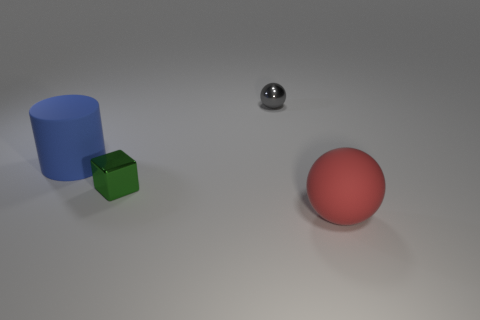What color is the ball behind the sphere in front of the small object that is on the right side of the tiny block?
Your answer should be very brief. Gray. Are the sphere that is in front of the large blue cylinder and the big object that is behind the red matte sphere made of the same material?
Offer a very short reply. Yes. What number of things are either red spheres in front of the green metallic block or big blue objects?
Provide a succinct answer. 2. How many things are large blue shiny cylinders or things that are on the left side of the gray metal object?
Your response must be concise. 2. How many objects are the same size as the gray metal ball?
Your answer should be compact. 1. Is the number of blue cylinders that are in front of the tiny metal cube less than the number of things behind the rubber sphere?
Ensure brevity in your answer.  Yes. How many shiny objects are either red things or small green cylinders?
Provide a succinct answer. 0. What is the shape of the red matte thing?
Provide a short and direct response. Sphere. What material is the red ball that is the same size as the blue rubber thing?
Provide a succinct answer. Rubber. What number of small objects are either matte balls or blue cylinders?
Offer a terse response. 0. 